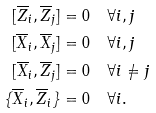<formula> <loc_0><loc_0><loc_500><loc_500>[ \overline { Z } _ { i } , \overline { Z } _ { j } ] & = 0 \quad \forall i , j \\ [ \overline { X } _ { i } , \overline { X } _ { j } ] & = 0 \quad \forall i , j \\ [ \overline { X } _ { i } , \overline { Z } _ { j } ] & = 0 \quad \forall i \neq j \\ \{ \overline { X } _ { i } , \overline { Z } _ { i } \} & = 0 \quad \forall i .</formula> 